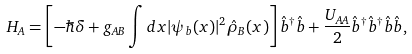Convert formula to latex. <formula><loc_0><loc_0><loc_500><loc_500>H _ { A } = \left [ - \hbar { \delta } + { g _ { A B } \int d { x } | \psi _ { b } ( { x } ) | ^ { 2 } \hat { \rho } _ { B } ( { x } ) } \right ] \hat { b } ^ { \dagger } \hat { b } + \frac { U _ { A A } } { 2 } \hat { b } ^ { \dagger } \hat { b } ^ { \dagger } \hat { b } \hat { b } ,</formula> 